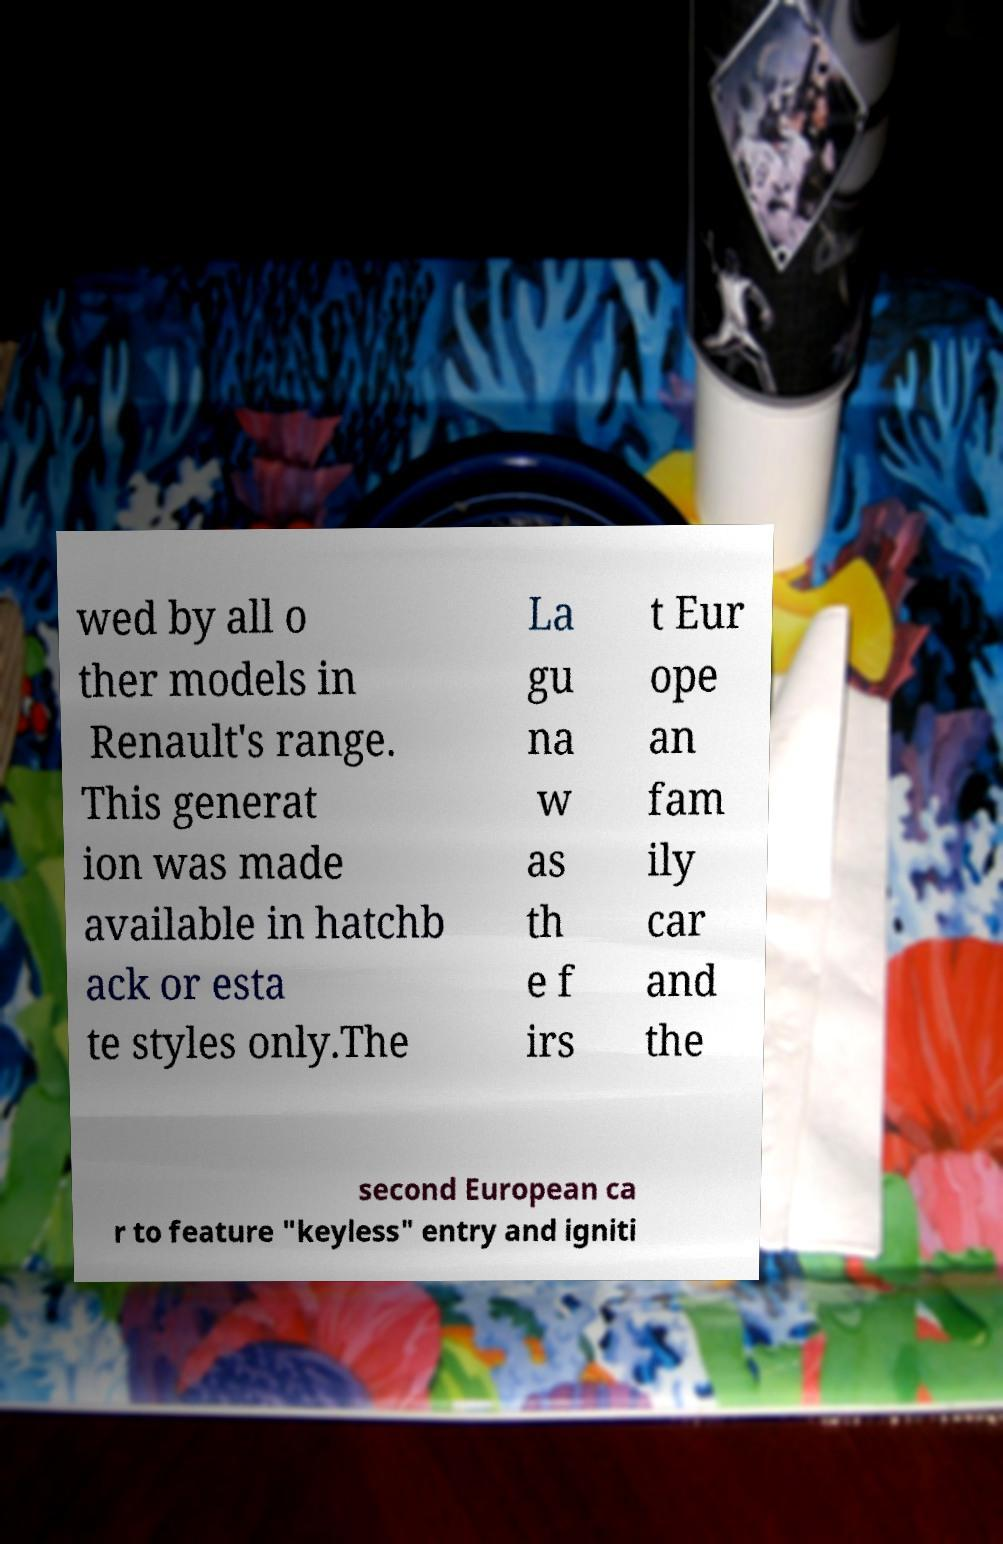Could you assist in decoding the text presented in this image and type it out clearly? wed by all o ther models in Renault's range. This generat ion was made available in hatchb ack or esta te styles only.The La gu na w as th e f irs t Eur ope an fam ily car and the second European ca r to feature "keyless" entry and igniti 